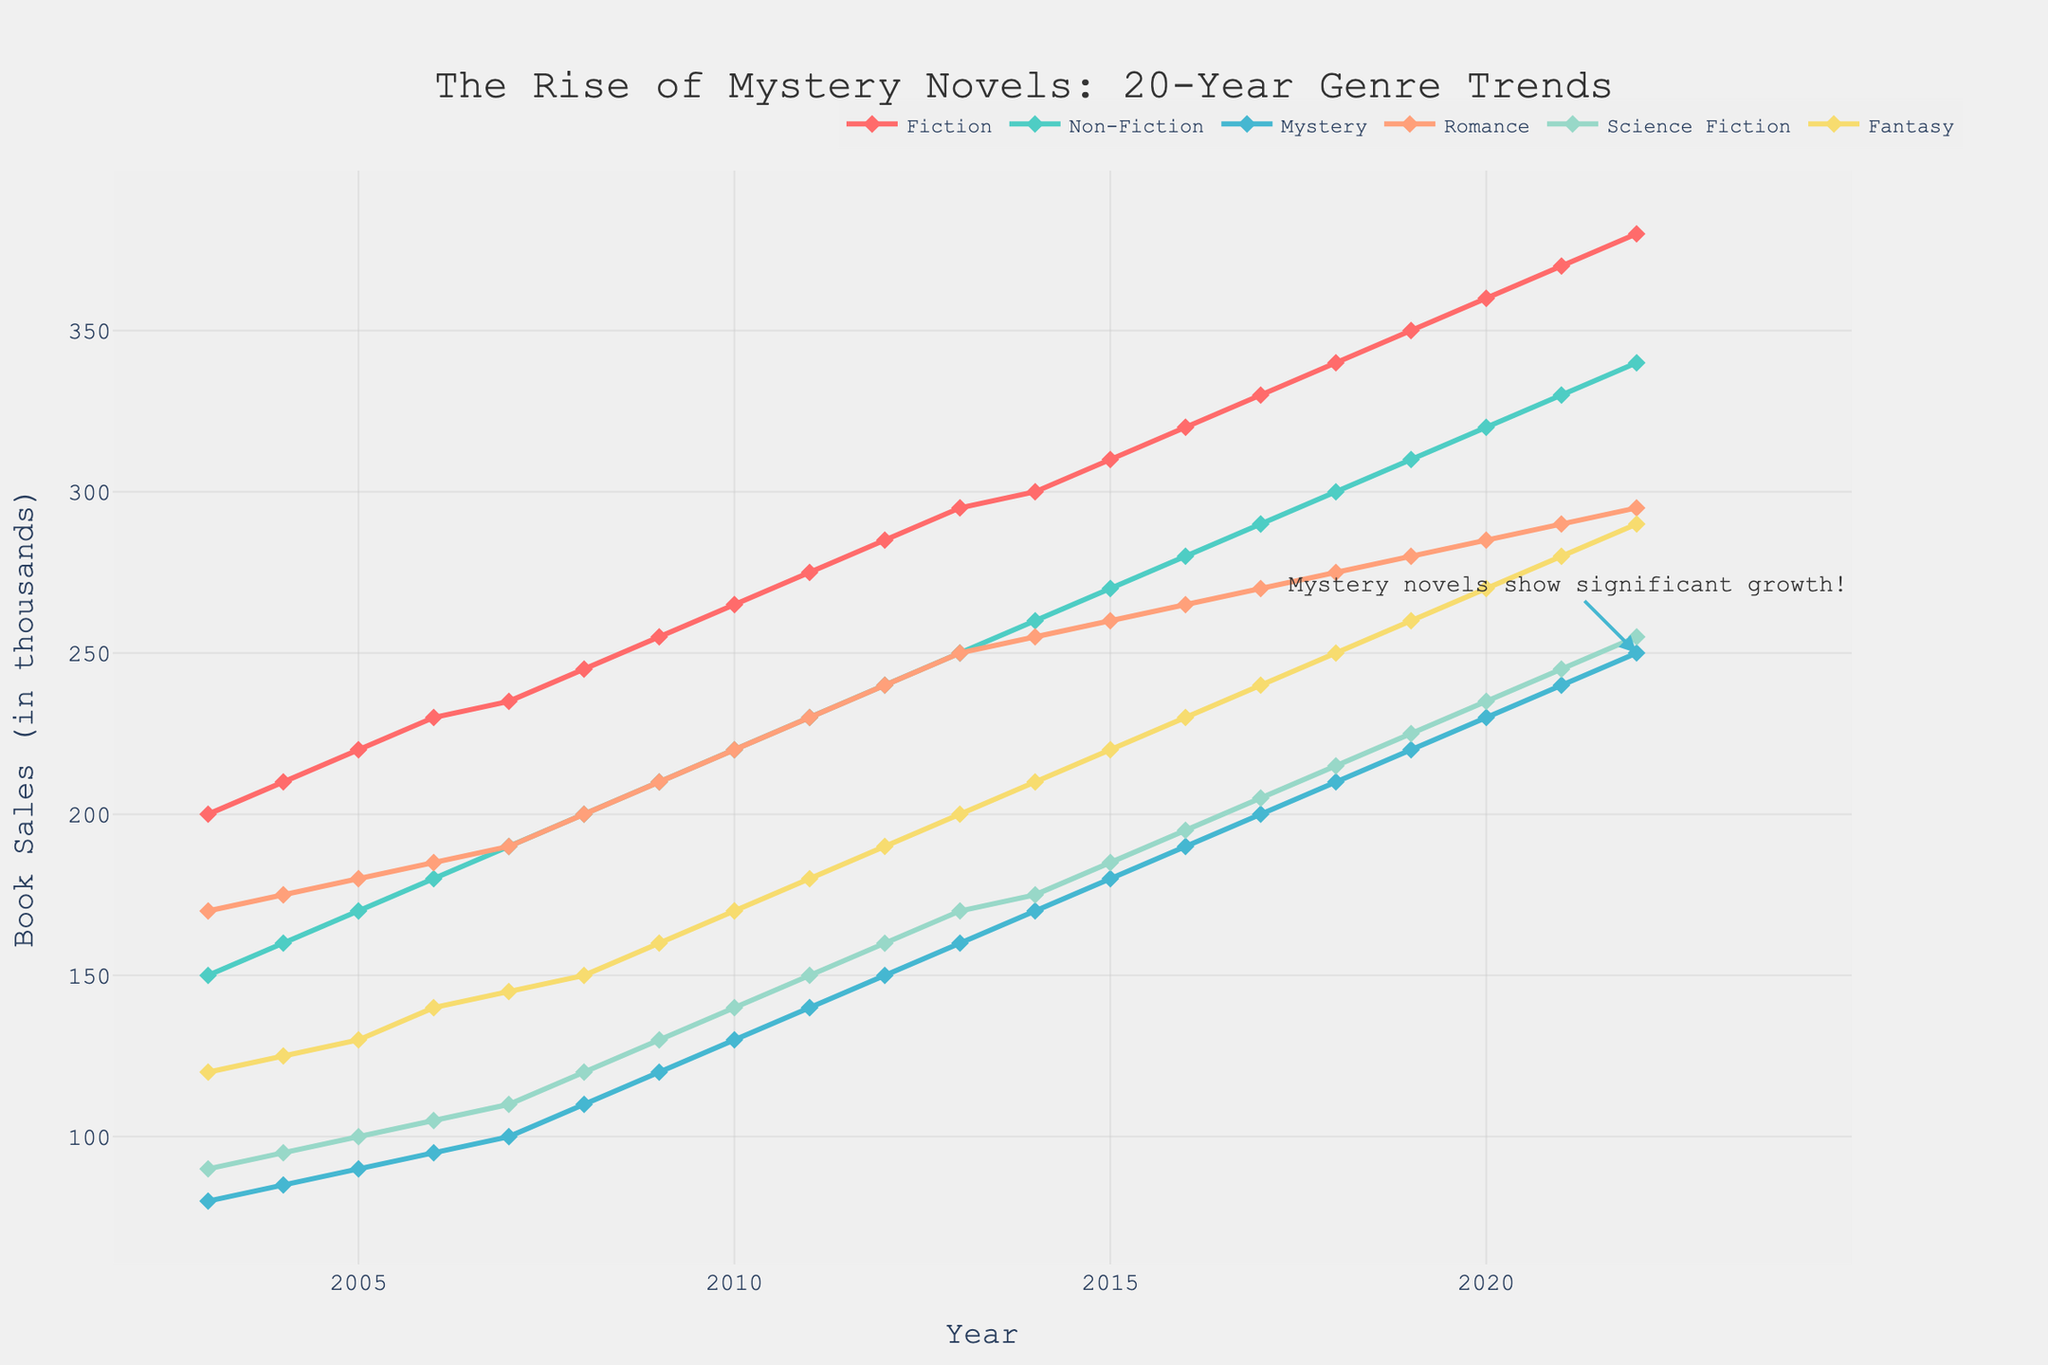Which genre had the highest sales in 2022? In the figure, we see the sales trends across different genres. By looking at the far right end of the graph for 2022, Fiction is the top line, indicating the highest sales.
Answer: Fiction Between which years did mystery novels see the sharpest increase in sales? Observing the trend lines for Mystery, the steepest incline appears around 2008 to 2013, where the line showing sales is nearly vertical.
Answer: 2008 to 2013 How many genres are shown in the figure? Looking at the legend above the plot, the figure highlights six different genres: Fiction, Non-Fiction, Mystery, Romance, Science Fiction, and Fantasy.
Answer: 6 Was there any year when mystery novels outsold Romance novels? Tracking the Mystery and Romance lines, we see Mystery novels consistently below Romance sales each year. Thus, there was no such year.
Answer: No What is the approximate increase in sales of science fiction books from 2003 to 2022? Looking at the Science Fiction line, sales started at around 90,000 (2003) and rose to approximately 255,000 (2022). The difference is about 165,000.
Answer: 165,000 Which genre showed the least growth over the 20-year period? All lines show growth, but Non-Fiction's increase from about 150,000 to 340,000 is the least compared to others visually.
Answer: Non-Fiction If the trend continues, which genre is likely to surpass 400,000 sales first? Fiction sales, presently at 380,000 and the highest trajectory, are closest to 400,000 and will likely reach it first if the trend continues.
Answer: Fiction What was the sales figure for Romance novels in 2015? On the Romance line for 2015, we intersect just above 260,000, close to 265,000.
Answer: 260,000 How does the sharpness of the rise in Mystery novels compare to Fantasy novels around the middle of the timeline? Around 2010-2015, the Mystery line shows a steeper incline than the Fantasy line. Meaning, Mystery books' sales grew more rapidly in this period.
Answer: Faster When did Fantasy novels reach 200,000 sales? The crossover for Fantasy at 200,000 appears around 2013, as the figure shows the corresponding trend line passed this point that year.
Answer: 2013 